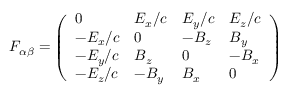Convert formula to latex. <formula><loc_0><loc_0><loc_500><loc_500>F _ { \alpha \beta } = \left ( { \begin{array} { l l l l } { 0 } & { E _ { x } / c } & { E _ { y } / c } & { E _ { z } / c } \\ { - E _ { x } / c } & { 0 } & { - B _ { z } } & { B _ { y } } \\ { - E _ { y } / c } & { B _ { z } } & { 0 } & { - B _ { x } } \\ { - E _ { z } / c } & { - B _ { y } } & { B _ { x } } & { 0 } \end{array} } \right )</formula> 